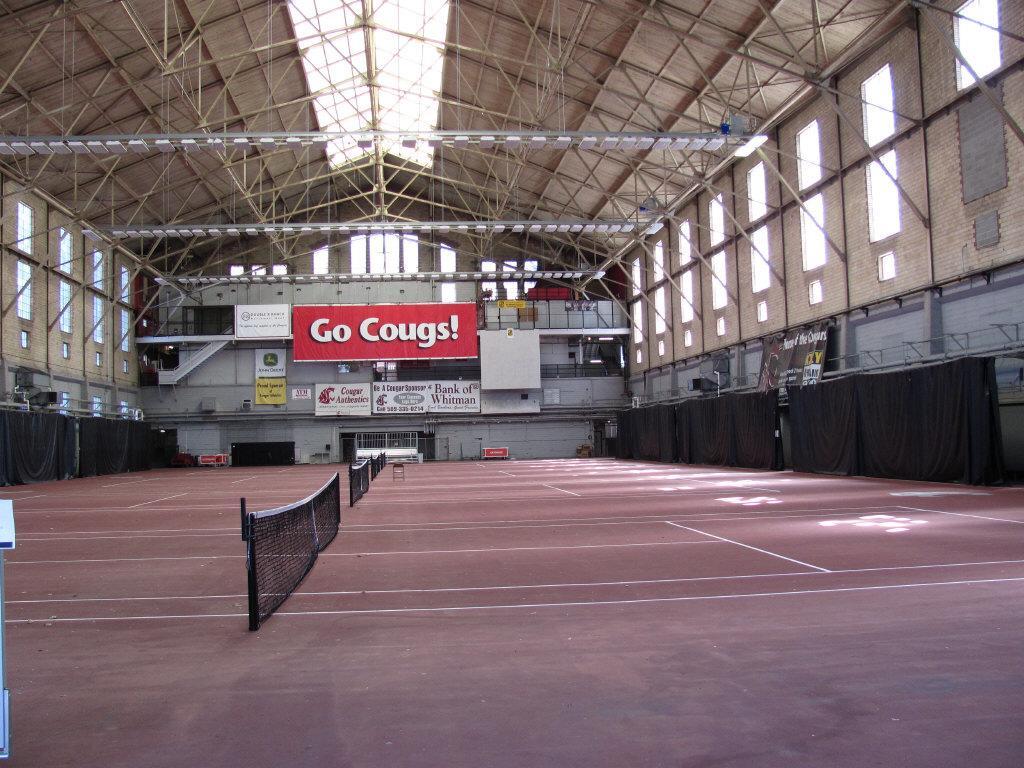Can you describe this image briefly? In the picture I can see few nets and there are few black clothes on either sides of it and there are few banners which has something written on it in the background and there are few rods and poles above it. 